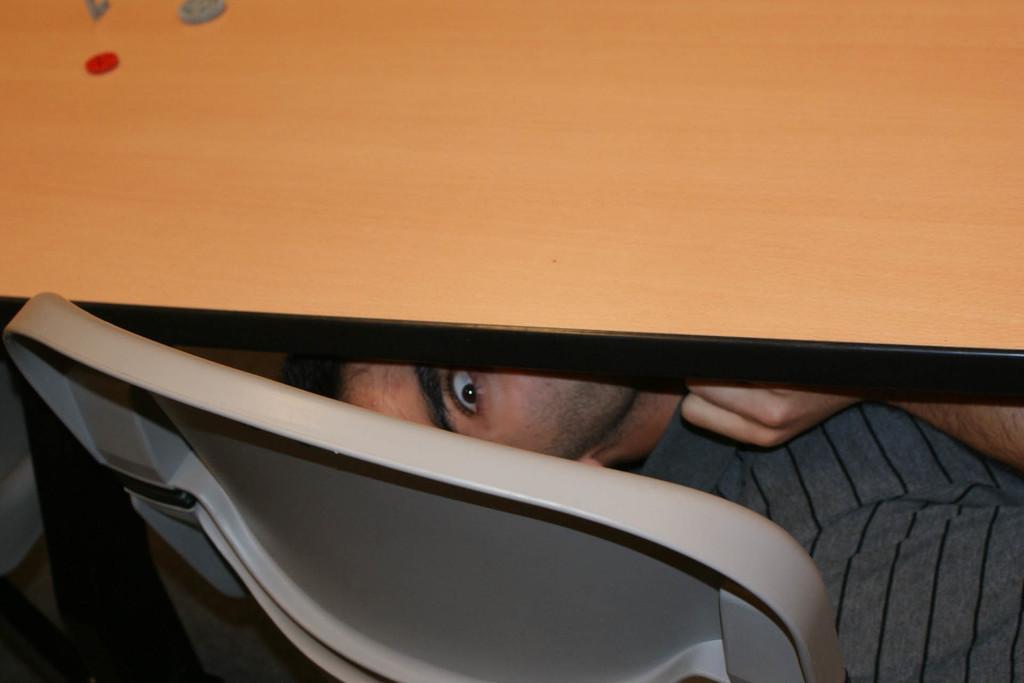In one or two sentences, can you explain what this image depicts? In this image I can see a table and under it I can see a man. I can also see he is wearing grey color dress and in the front I can see a chair like thing. On the top left side of this image I can see few things on the table. 